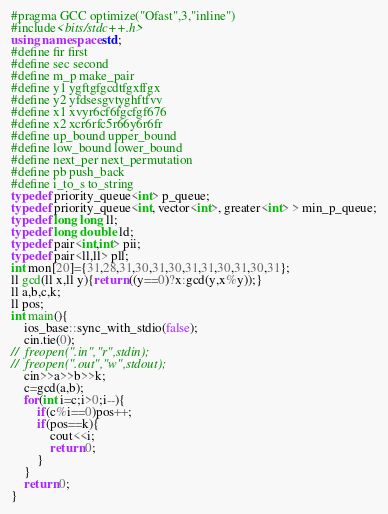Convert code to text. <code><loc_0><loc_0><loc_500><loc_500><_C++_>#pragma GCC optimize("Ofast",3,"inline")
#include<bits/stdc++.h>
using namespace std;
#define fir first
#define sec second
#define m_p make_pair
#define y1 ygftgfgcdtfgxffgx
#define y2 yfdsesgvtyghftfvv
#define x1 xvyr6cf6fgcfgf676
#define x2 xcr6rfc5r66y6r6fr
#define up_bound upper_bound
#define low_bound lower_bound
#define next_per next_permutation
#define pb push_back
#define i_to_s to_string
typedef priority_queue<int> p_queue;
typedef priority_queue<int, vector<int>, greater<int> > min_p_queue;
typedef long long ll;
typedef long double ld;
typedef pair<int,int> pii;
typedef pair<ll,ll> pll;
int mon[20]={31,28,31,30,31,30,31,31,30,31,30,31};
ll gcd(ll x,ll y){return ((y==0)?x:gcd(y,x%y));}
ll a,b,c,k;
ll pos;
int main(){
	ios_base::sync_with_stdio(false);
	cin.tie(0);
//	freopen(".in","r",stdin);
//	freopen(".out","w",stdout);
	cin>>a>>b>>k;
	c=gcd(a,b);
	for(int i=c;i>0;i--){
		if(c%i==0)pos++;
		if(pos==k){
			cout<<i;
			return 0;
		}
	}
	return 0;
}
</code> 